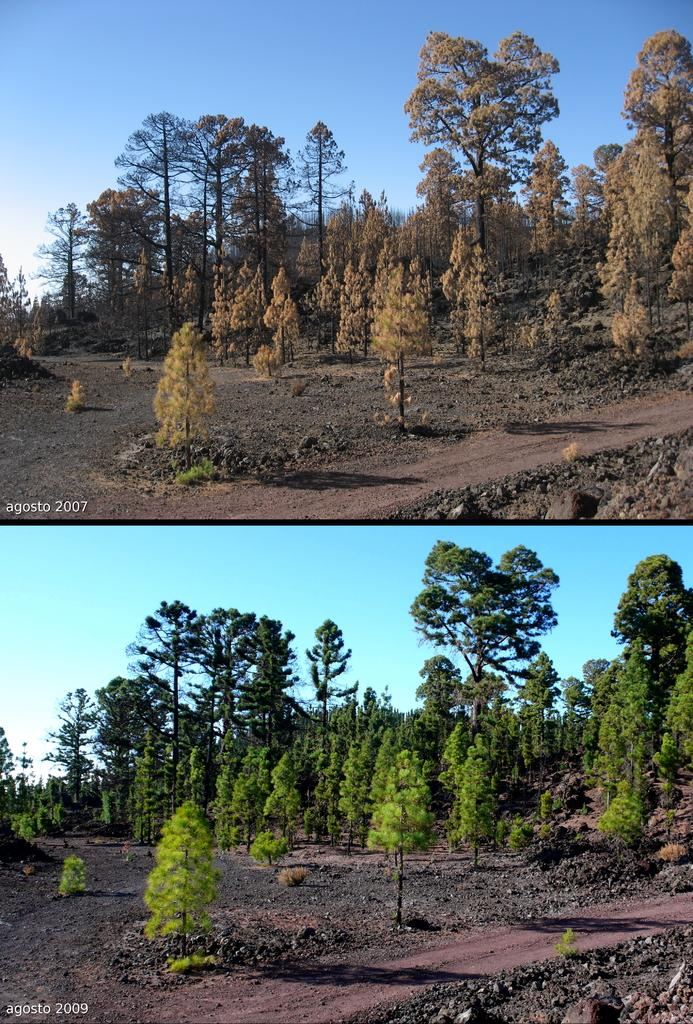What type of natural elements can be seen in the image? The image contains a group of trees. What man-made feature is present in the image? There is a pathway in the image. What type of ground surface can be seen in the image? Some stones are present in the image. What is visible in the background of the image? The sky is visible in the image. How would you describe the weather based on the sky in the image? The sky appears to be cloudy in the image. How many dimes are scattered on the ground in the image? There are no dimes present in the image; it features a group of trees, a pathway, stones, and a cloudy sky. 